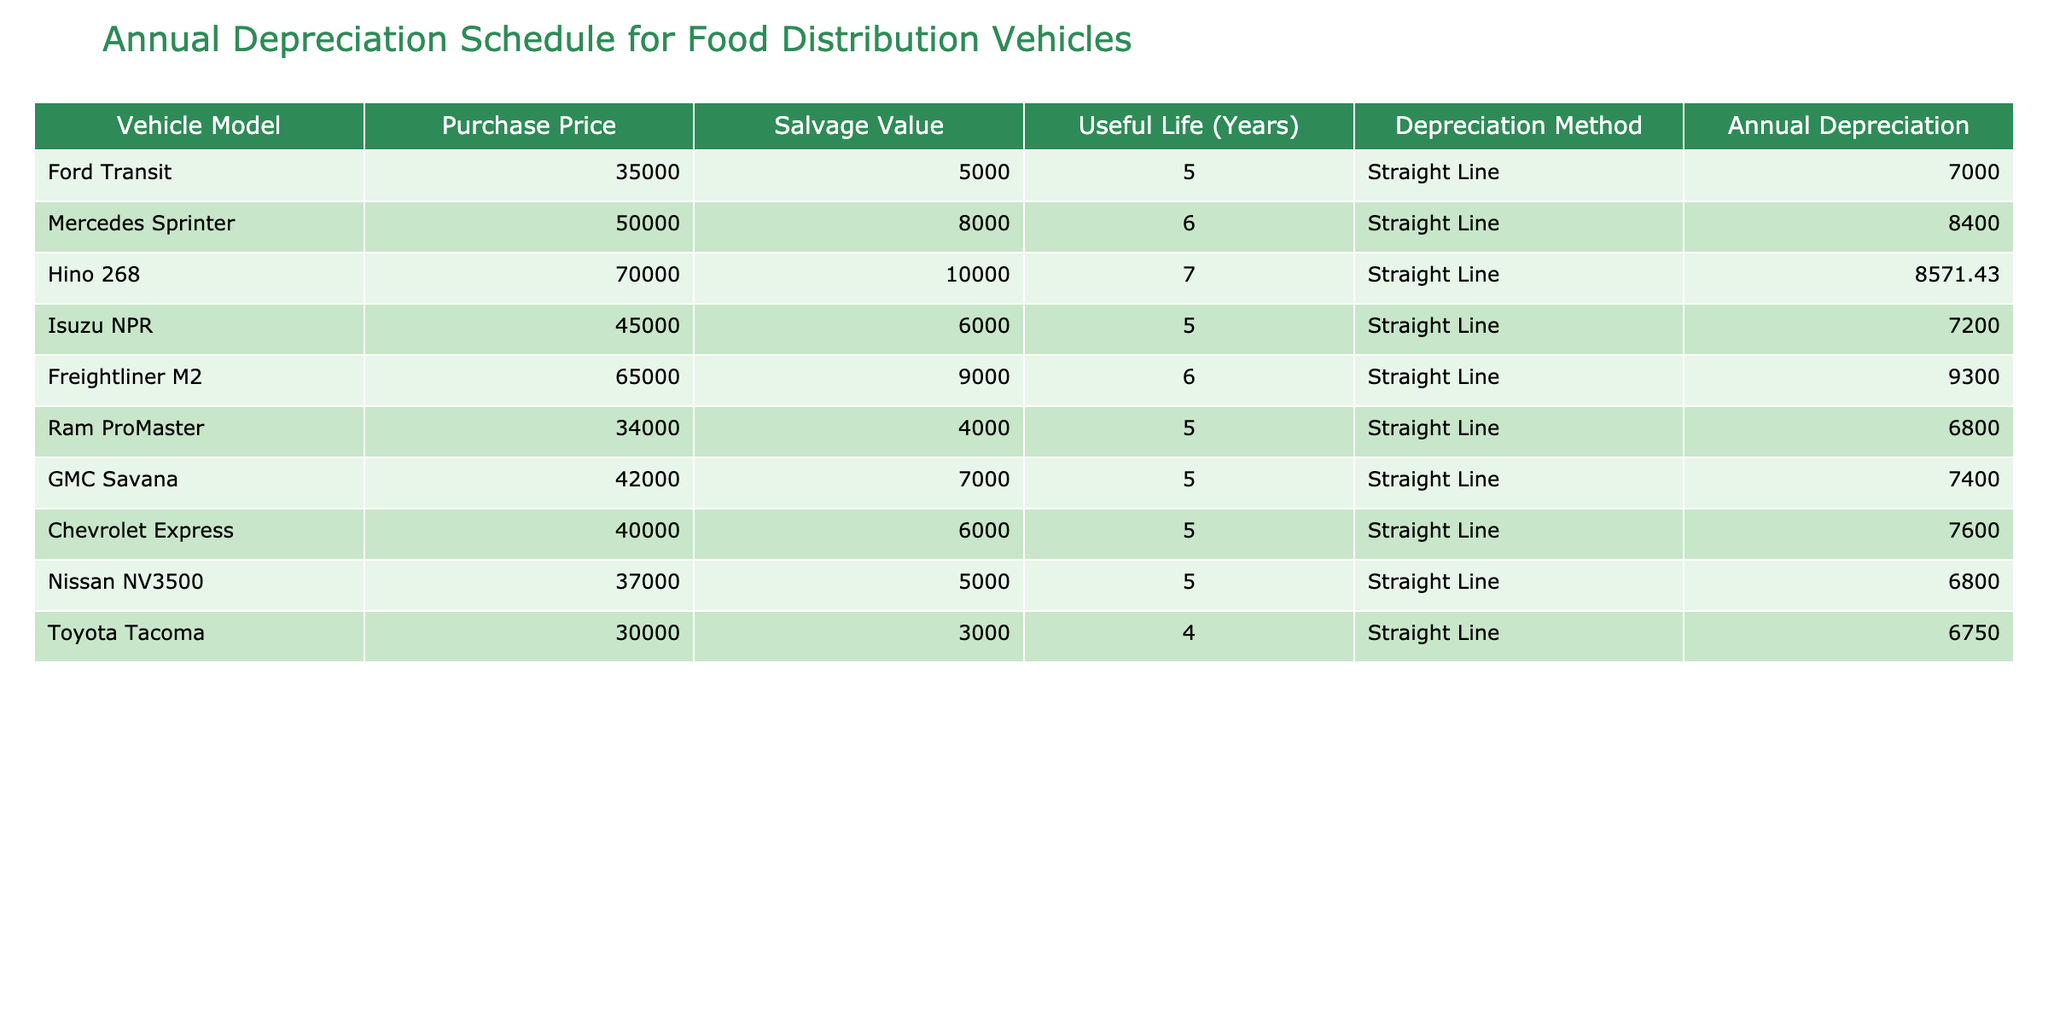What is the annual depreciation for the Ford Transit? The annual depreciation for the Ford Transit is directly listed in the table under the column "Annual Depreciation," which shows a value of 7000.
Answer: 7000 Which vehicle has the highest annual depreciation? By comparing the "Annual Depreciation" column values, the Hino 268 has the highest annual depreciation at 8571.43.
Answer: Hino 268 How many vehicles have an annual depreciation of 7000 or more? To determine this, I count the number of values in the "Annual Depreciation" column that are 7000 or higher: Ford Transit, Mercedes Sprinter, Hino 268, Freightliner M2, and GMC Savana, totaling 5 vehicles.
Answer: 5 What is the average annual depreciation of all vehicles? Adding together all the annual depreciation values gives (7000 + 8400 + 8571.43 + 7200 + 9300 + 6800 + 7400 + 7600 + 6800 + 6750) = 70,222.43. Dividing this by the number of vehicles (10) gives an average of 7022.24.
Answer: 7022.24 Is the salvage value of the Mercedes Sprinter more than 7000? The salvage value for the Mercedes Sprinter is listed as 8000 in the table, which is indeed greater than 7000.
Answer: Yes Which vehicle has the longest useful life and what is it? The vehicle with the longest useful life is the Hino 268, which has a useful life of 7 years as shown in the "Useful Life (Years)" column.
Answer: Hino 268, 7 years What is the total depreciation for all vehicles after 5 years? First, calculate the annual depreciation summed up for 5 years: (7000 + 8400 + 8571.43 + 7200 + 9300 + 6800 + 7400 + 7600 + 6800 + 6750) × 5 = 351,111.15. This calculates total depreciation depreciation for all vehicles after 5 years.
Answer: 351,111.15 Is the Toyota Tacoma's annual depreciation lower than 7000? The annual depreciation for the Toyota Tacoma is 6750, which is indeed lower than 7000.
Answer: Yes 